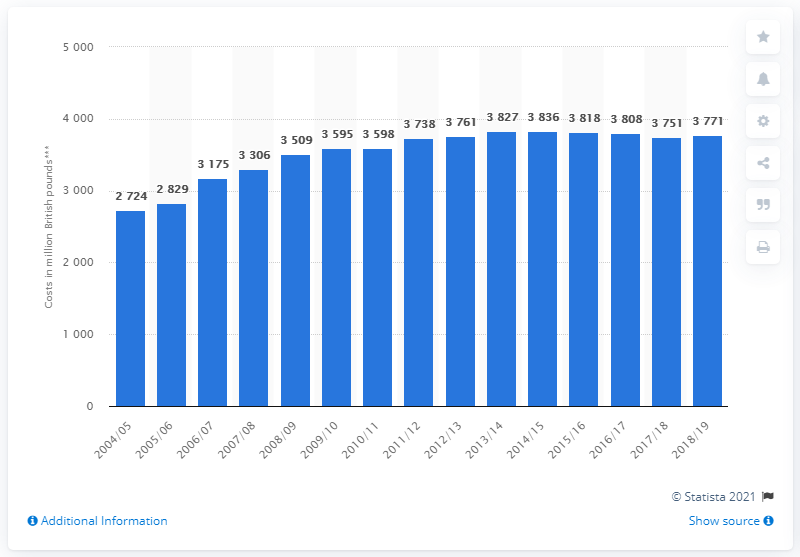Highlight a few significant elements in this photo. The operating costs of buses in 2014/15 were approximately 3,808. 